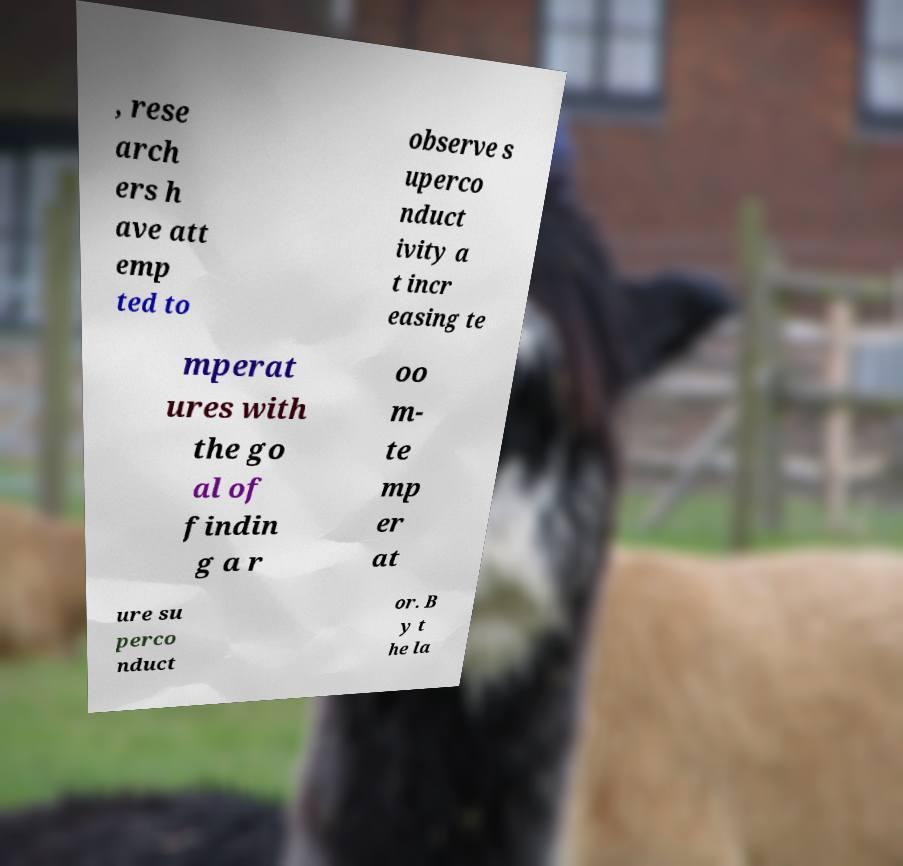Please read and relay the text visible in this image. What does it say? , rese arch ers h ave att emp ted to observe s uperco nduct ivity a t incr easing te mperat ures with the go al of findin g a r oo m- te mp er at ure su perco nduct or. B y t he la 